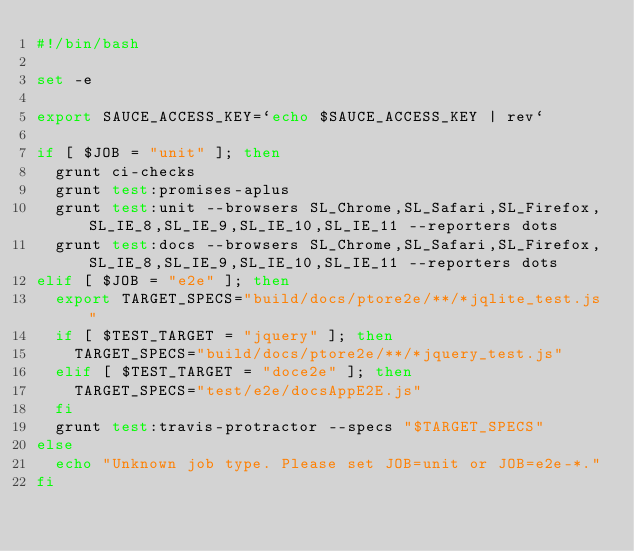Convert code to text. <code><loc_0><loc_0><loc_500><loc_500><_Bash_>#!/bin/bash

set -e

export SAUCE_ACCESS_KEY=`echo $SAUCE_ACCESS_KEY | rev`

if [ $JOB = "unit" ]; then
  grunt ci-checks
  grunt test:promises-aplus
  grunt test:unit --browsers SL_Chrome,SL_Safari,SL_Firefox,SL_IE_8,SL_IE_9,SL_IE_10,SL_IE_11 --reporters dots
  grunt test:docs --browsers SL_Chrome,SL_Safari,SL_Firefox,SL_IE_8,SL_IE_9,SL_IE_10,SL_IE_11 --reporters dots
elif [ $JOB = "e2e" ]; then
  export TARGET_SPECS="build/docs/ptore2e/**/*jqlite_test.js"
  if [ $TEST_TARGET = "jquery" ]; then
    TARGET_SPECS="build/docs/ptore2e/**/*jquery_test.js"
  elif [ $TEST_TARGET = "doce2e" ]; then
    TARGET_SPECS="test/e2e/docsAppE2E.js"
  fi
  grunt test:travis-protractor --specs "$TARGET_SPECS"
else
  echo "Unknown job type. Please set JOB=unit or JOB=e2e-*."
fi
</code> 